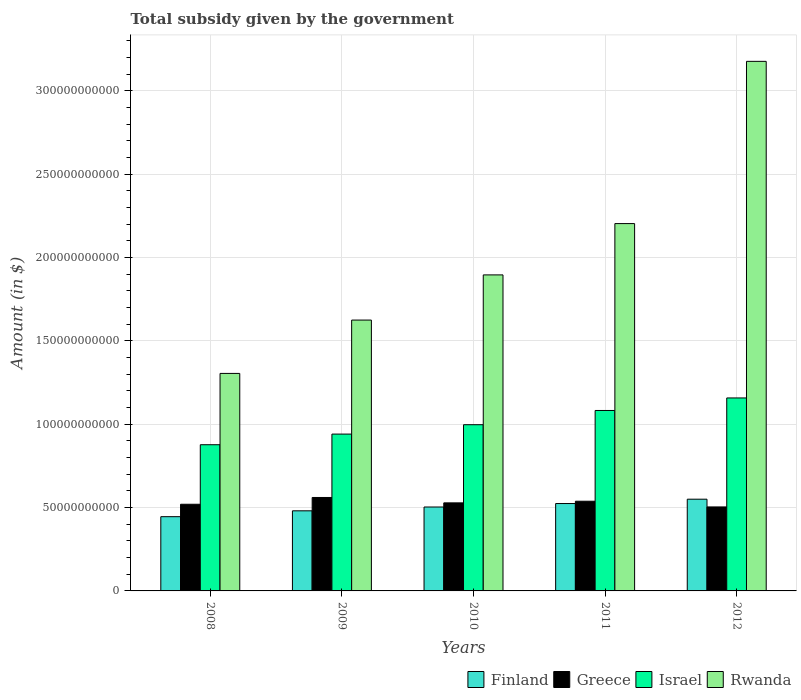Are the number of bars per tick equal to the number of legend labels?
Make the answer very short. Yes. What is the label of the 2nd group of bars from the left?
Give a very brief answer. 2009. In how many cases, is the number of bars for a given year not equal to the number of legend labels?
Keep it short and to the point. 0. What is the total revenue collected by the government in Finland in 2010?
Your answer should be very brief. 5.03e+1. Across all years, what is the maximum total revenue collected by the government in Rwanda?
Offer a very short reply. 3.18e+11. Across all years, what is the minimum total revenue collected by the government in Greece?
Give a very brief answer. 5.04e+1. In which year was the total revenue collected by the government in Israel minimum?
Offer a terse response. 2008. What is the total total revenue collected by the government in Greece in the graph?
Provide a succinct answer. 2.65e+11. What is the difference between the total revenue collected by the government in Rwanda in 2008 and that in 2010?
Offer a terse response. -5.91e+1. What is the difference between the total revenue collected by the government in Israel in 2011 and the total revenue collected by the government in Rwanda in 2012?
Give a very brief answer. -2.09e+11. What is the average total revenue collected by the government in Rwanda per year?
Your answer should be compact. 2.04e+11. In the year 2010, what is the difference between the total revenue collected by the government in Finland and total revenue collected by the government in Rwanda?
Your answer should be compact. -1.39e+11. In how many years, is the total revenue collected by the government in Greece greater than 50000000000 $?
Offer a very short reply. 5. What is the ratio of the total revenue collected by the government in Israel in 2010 to that in 2012?
Your answer should be compact. 0.86. Is the total revenue collected by the government in Israel in 2010 less than that in 2012?
Offer a terse response. Yes. What is the difference between the highest and the second highest total revenue collected by the government in Greece?
Keep it short and to the point. 2.25e+09. What is the difference between the highest and the lowest total revenue collected by the government in Finland?
Give a very brief answer. 1.05e+1. Is the sum of the total revenue collected by the government in Finland in 2010 and 2011 greater than the maximum total revenue collected by the government in Israel across all years?
Provide a short and direct response. No. What does the 1st bar from the left in 2011 represents?
Keep it short and to the point. Finland. What does the 1st bar from the right in 2012 represents?
Your answer should be very brief. Rwanda. How many bars are there?
Offer a terse response. 20. Are all the bars in the graph horizontal?
Your answer should be compact. No. How many years are there in the graph?
Keep it short and to the point. 5. What is the difference between two consecutive major ticks on the Y-axis?
Ensure brevity in your answer.  5.00e+1. Does the graph contain any zero values?
Provide a short and direct response. No. Where does the legend appear in the graph?
Your answer should be compact. Bottom right. How many legend labels are there?
Ensure brevity in your answer.  4. What is the title of the graph?
Give a very brief answer. Total subsidy given by the government. What is the label or title of the X-axis?
Keep it short and to the point. Years. What is the label or title of the Y-axis?
Give a very brief answer. Amount (in $). What is the Amount (in $) in Finland in 2008?
Provide a short and direct response. 4.45e+1. What is the Amount (in $) of Greece in 2008?
Offer a very short reply. 5.20e+1. What is the Amount (in $) of Israel in 2008?
Offer a very short reply. 8.77e+1. What is the Amount (in $) in Rwanda in 2008?
Keep it short and to the point. 1.30e+11. What is the Amount (in $) in Finland in 2009?
Your answer should be compact. 4.80e+1. What is the Amount (in $) of Greece in 2009?
Make the answer very short. 5.60e+1. What is the Amount (in $) in Israel in 2009?
Offer a terse response. 9.41e+1. What is the Amount (in $) in Rwanda in 2009?
Provide a succinct answer. 1.62e+11. What is the Amount (in $) in Finland in 2010?
Make the answer very short. 5.03e+1. What is the Amount (in $) of Greece in 2010?
Your answer should be very brief. 5.28e+1. What is the Amount (in $) of Israel in 2010?
Keep it short and to the point. 9.97e+1. What is the Amount (in $) of Rwanda in 2010?
Keep it short and to the point. 1.90e+11. What is the Amount (in $) in Finland in 2011?
Your answer should be compact. 5.24e+1. What is the Amount (in $) in Greece in 2011?
Give a very brief answer. 5.38e+1. What is the Amount (in $) in Israel in 2011?
Offer a very short reply. 1.08e+11. What is the Amount (in $) of Rwanda in 2011?
Offer a very short reply. 2.20e+11. What is the Amount (in $) of Finland in 2012?
Keep it short and to the point. 5.50e+1. What is the Amount (in $) of Greece in 2012?
Make the answer very short. 5.04e+1. What is the Amount (in $) in Israel in 2012?
Your response must be concise. 1.16e+11. What is the Amount (in $) of Rwanda in 2012?
Provide a succinct answer. 3.18e+11. Across all years, what is the maximum Amount (in $) in Finland?
Your answer should be very brief. 5.50e+1. Across all years, what is the maximum Amount (in $) of Greece?
Give a very brief answer. 5.60e+1. Across all years, what is the maximum Amount (in $) of Israel?
Provide a succinct answer. 1.16e+11. Across all years, what is the maximum Amount (in $) of Rwanda?
Your response must be concise. 3.18e+11. Across all years, what is the minimum Amount (in $) of Finland?
Your answer should be compact. 4.45e+1. Across all years, what is the minimum Amount (in $) in Greece?
Offer a very short reply. 5.04e+1. Across all years, what is the minimum Amount (in $) in Israel?
Your answer should be compact. 8.77e+1. Across all years, what is the minimum Amount (in $) of Rwanda?
Provide a short and direct response. 1.30e+11. What is the total Amount (in $) in Finland in the graph?
Provide a succinct answer. 2.50e+11. What is the total Amount (in $) in Greece in the graph?
Make the answer very short. 2.65e+11. What is the total Amount (in $) of Israel in the graph?
Make the answer very short. 5.05e+11. What is the total Amount (in $) of Rwanda in the graph?
Your answer should be very brief. 1.02e+12. What is the difference between the Amount (in $) in Finland in 2008 and that in 2009?
Provide a succinct answer. -3.52e+09. What is the difference between the Amount (in $) in Greece in 2008 and that in 2009?
Make the answer very short. -4.07e+09. What is the difference between the Amount (in $) of Israel in 2008 and that in 2009?
Make the answer very short. -6.38e+09. What is the difference between the Amount (in $) in Rwanda in 2008 and that in 2009?
Ensure brevity in your answer.  -3.20e+1. What is the difference between the Amount (in $) in Finland in 2008 and that in 2010?
Ensure brevity in your answer.  -5.80e+09. What is the difference between the Amount (in $) in Greece in 2008 and that in 2010?
Ensure brevity in your answer.  -8.33e+08. What is the difference between the Amount (in $) of Israel in 2008 and that in 2010?
Keep it short and to the point. -1.20e+1. What is the difference between the Amount (in $) in Rwanda in 2008 and that in 2010?
Give a very brief answer. -5.91e+1. What is the difference between the Amount (in $) in Finland in 2008 and that in 2011?
Make the answer very short. -7.89e+09. What is the difference between the Amount (in $) of Greece in 2008 and that in 2011?
Give a very brief answer. -1.82e+09. What is the difference between the Amount (in $) in Israel in 2008 and that in 2011?
Your answer should be compact. -2.05e+1. What is the difference between the Amount (in $) in Rwanda in 2008 and that in 2011?
Your response must be concise. -8.99e+1. What is the difference between the Amount (in $) in Finland in 2008 and that in 2012?
Your answer should be very brief. -1.05e+1. What is the difference between the Amount (in $) of Greece in 2008 and that in 2012?
Your answer should be compact. 1.60e+09. What is the difference between the Amount (in $) of Israel in 2008 and that in 2012?
Offer a terse response. -2.81e+1. What is the difference between the Amount (in $) in Rwanda in 2008 and that in 2012?
Provide a short and direct response. -1.87e+11. What is the difference between the Amount (in $) of Finland in 2009 and that in 2010?
Make the answer very short. -2.28e+09. What is the difference between the Amount (in $) of Greece in 2009 and that in 2010?
Ensure brevity in your answer.  3.24e+09. What is the difference between the Amount (in $) of Israel in 2009 and that in 2010?
Your answer should be very brief. -5.62e+09. What is the difference between the Amount (in $) of Rwanda in 2009 and that in 2010?
Your response must be concise. -2.71e+1. What is the difference between the Amount (in $) of Finland in 2009 and that in 2011?
Keep it short and to the point. -4.37e+09. What is the difference between the Amount (in $) of Greece in 2009 and that in 2011?
Provide a short and direct response. 2.25e+09. What is the difference between the Amount (in $) in Israel in 2009 and that in 2011?
Give a very brief answer. -1.42e+1. What is the difference between the Amount (in $) in Rwanda in 2009 and that in 2011?
Provide a succinct answer. -5.79e+1. What is the difference between the Amount (in $) of Finland in 2009 and that in 2012?
Provide a short and direct response. -6.97e+09. What is the difference between the Amount (in $) of Greece in 2009 and that in 2012?
Keep it short and to the point. 5.67e+09. What is the difference between the Amount (in $) in Israel in 2009 and that in 2012?
Your response must be concise. -2.17e+1. What is the difference between the Amount (in $) of Rwanda in 2009 and that in 2012?
Provide a succinct answer. -1.55e+11. What is the difference between the Amount (in $) in Finland in 2010 and that in 2011?
Your answer should be very brief. -2.09e+09. What is the difference between the Amount (in $) in Greece in 2010 and that in 2011?
Keep it short and to the point. -9.91e+08. What is the difference between the Amount (in $) of Israel in 2010 and that in 2011?
Your answer should be compact. -8.54e+09. What is the difference between the Amount (in $) in Rwanda in 2010 and that in 2011?
Your response must be concise. -3.08e+1. What is the difference between the Amount (in $) of Finland in 2010 and that in 2012?
Ensure brevity in your answer.  -4.69e+09. What is the difference between the Amount (in $) in Greece in 2010 and that in 2012?
Your answer should be very brief. 2.43e+09. What is the difference between the Amount (in $) of Israel in 2010 and that in 2012?
Provide a short and direct response. -1.61e+1. What is the difference between the Amount (in $) of Rwanda in 2010 and that in 2012?
Offer a terse response. -1.28e+11. What is the difference between the Amount (in $) in Finland in 2011 and that in 2012?
Keep it short and to the point. -2.60e+09. What is the difference between the Amount (in $) in Greece in 2011 and that in 2012?
Give a very brief answer. 3.42e+09. What is the difference between the Amount (in $) in Israel in 2011 and that in 2012?
Provide a succinct answer. -7.51e+09. What is the difference between the Amount (in $) of Rwanda in 2011 and that in 2012?
Offer a very short reply. -9.73e+1. What is the difference between the Amount (in $) of Finland in 2008 and the Amount (in $) of Greece in 2009?
Give a very brief answer. -1.15e+1. What is the difference between the Amount (in $) of Finland in 2008 and the Amount (in $) of Israel in 2009?
Offer a very short reply. -4.95e+1. What is the difference between the Amount (in $) of Finland in 2008 and the Amount (in $) of Rwanda in 2009?
Provide a short and direct response. -1.18e+11. What is the difference between the Amount (in $) of Greece in 2008 and the Amount (in $) of Israel in 2009?
Give a very brief answer. -4.21e+1. What is the difference between the Amount (in $) of Greece in 2008 and the Amount (in $) of Rwanda in 2009?
Make the answer very short. -1.10e+11. What is the difference between the Amount (in $) of Israel in 2008 and the Amount (in $) of Rwanda in 2009?
Provide a succinct answer. -7.48e+1. What is the difference between the Amount (in $) of Finland in 2008 and the Amount (in $) of Greece in 2010?
Your answer should be very brief. -8.28e+09. What is the difference between the Amount (in $) of Finland in 2008 and the Amount (in $) of Israel in 2010?
Provide a short and direct response. -5.52e+1. What is the difference between the Amount (in $) of Finland in 2008 and the Amount (in $) of Rwanda in 2010?
Provide a succinct answer. -1.45e+11. What is the difference between the Amount (in $) in Greece in 2008 and the Amount (in $) in Israel in 2010?
Make the answer very short. -4.77e+1. What is the difference between the Amount (in $) in Greece in 2008 and the Amount (in $) in Rwanda in 2010?
Your answer should be very brief. -1.38e+11. What is the difference between the Amount (in $) in Israel in 2008 and the Amount (in $) in Rwanda in 2010?
Keep it short and to the point. -1.02e+11. What is the difference between the Amount (in $) of Finland in 2008 and the Amount (in $) of Greece in 2011?
Your answer should be compact. -9.28e+09. What is the difference between the Amount (in $) of Finland in 2008 and the Amount (in $) of Israel in 2011?
Ensure brevity in your answer.  -6.37e+1. What is the difference between the Amount (in $) in Finland in 2008 and the Amount (in $) in Rwanda in 2011?
Provide a short and direct response. -1.76e+11. What is the difference between the Amount (in $) in Greece in 2008 and the Amount (in $) in Israel in 2011?
Your answer should be very brief. -5.62e+1. What is the difference between the Amount (in $) in Greece in 2008 and the Amount (in $) in Rwanda in 2011?
Give a very brief answer. -1.68e+11. What is the difference between the Amount (in $) of Israel in 2008 and the Amount (in $) of Rwanda in 2011?
Keep it short and to the point. -1.33e+11. What is the difference between the Amount (in $) in Finland in 2008 and the Amount (in $) in Greece in 2012?
Ensure brevity in your answer.  -5.85e+09. What is the difference between the Amount (in $) of Finland in 2008 and the Amount (in $) of Israel in 2012?
Give a very brief answer. -7.12e+1. What is the difference between the Amount (in $) of Finland in 2008 and the Amount (in $) of Rwanda in 2012?
Provide a succinct answer. -2.73e+11. What is the difference between the Amount (in $) of Greece in 2008 and the Amount (in $) of Israel in 2012?
Provide a short and direct response. -6.38e+1. What is the difference between the Amount (in $) of Greece in 2008 and the Amount (in $) of Rwanda in 2012?
Make the answer very short. -2.66e+11. What is the difference between the Amount (in $) of Israel in 2008 and the Amount (in $) of Rwanda in 2012?
Provide a short and direct response. -2.30e+11. What is the difference between the Amount (in $) of Finland in 2009 and the Amount (in $) of Greece in 2010?
Ensure brevity in your answer.  -4.76e+09. What is the difference between the Amount (in $) of Finland in 2009 and the Amount (in $) of Israel in 2010?
Give a very brief answer. -5.16e+1. What is the difference between the Amount (in $) in Finland in 2009 and the Amount (in $) in Rwanda in 2010?
Ensure brevity in your answer.  -1.41e+11. What is the difference between the Amount (in $) of Greece in 2009 and the Amount (in $) of Israel in 2010?
Provide a succinct answer. -4.36e+1. What is the difference between the Amount (in $) of Greece in 2009 and the Amount (in $) of Rwanda in 2010?
Give a very brief answer. -1.33e+11. What is the difference between the Amount (in $) in Israel in 2009 and the Amount (in $) in Rwanda in 2010?
Your answer should be compact. -9.55e+1. What is the difference between the Amount (in $) of Finland in 2009 and the Amount (in $) of Greece in 2011?
Give a very brief answer. -5.75e+09. What is the difference between the Amount (in $) of Finland in 2009 and the Amount (in $) of Israel in 2011?
Give a very brief answer. -6.02e+1. What is the difference between the Amount (in $) in Finland in 2009 and the Amount (in $) in Rwanda in 2011?
Keep it short and to the point. -1.72e+11. What is the difference between the Amount (in $) in Greece in 2009 and the Amount (in $) in Israel in 2011?
Your response must be concise. -5.22e+1. What is the difference between the Amount (in $) of Greece in 2009 and the Amount (in $) of Rwanda in 2011?
Give a very brief answer. -1.64e+11. What is the difference between the Amount (in $) of Israel in 2009 and the Amount (in $) of Rwanda in 2011?
Ensure brevity in your answer.  -1.26e+11. What is the difference between the Amount (in $) of Finland in 2009 and the Amount (in $) of Greece in 2012?
Make the answer very short. -2.33e+09. What is the difference between the Amount (in $) in Finland in 2009 and the Amount (in $) in Israel in 2012?
Keep it short and to the point. -6.77e+1. What is the difference between the Amount (in $) of Finland in 2009 and the Amount (in $) of Rwanda in 2012?
Offer a terse response. -2.70e+11. What is the difference between the Amount (in $) of Greece in 2009 and the Amount (in $) of Israel in 2012?
Make the answer very short. -5.97e+1. What is the difference between the Amount (in $) in Greece in 2009 and the Amount (in $) in Rwanda in 2012?
Keep it short and to the point. -2.62e+11. What is the difference between the Amount (in $) in Israel in 2009 and the Amount (in $) in Rwanda in 2012?
Your response must be concise. -2.24e+11. What is the difference between the Amount (in $) in Finland in 2010 and the Amount (in $) in Greece in 2011?
Your answer should be compact. -3.47e+09. What is the difference between the Amount (in $) in Finland in 2010 and the Amount (in $) in Israel in 2011?
Keep it short and to the point. -5.79e+1. What is the difference between the Amount (in $) of Finland in 2010 and the Amount (in $) of Rwanda in 2011?
Make the answer very short. -1.70e+11. What is the difference between the Amount (in $) of Greece in 2010 and the Amount (in $) of Israel in 2011?
Provide a short and direct response. -5.54e+1. What is the difference between the Amount (in $) of Greece in 2010 and the Amount (in $) of Rwanda in 2011?
Provide a succinct answer. -1.67e+11. What is the difference between the Amount (in $) in Israel in 2010 and the Amount (in $) in Rwanda in 2011?
Your answer should be very brief. -1.21e+11. What is the difference between the Amount (in $) in Finland in 2010 and the Amount (in $) in Greece in 2012?
Your answer should be compact. -5.30e+07. What is the difference between the Amount (in $) of Finland in 2010 and the Amount (in $) of Israel in 2012?
Offer a very short reply. -6.54e+1. What is the difference between the Amount (in $) of Finland in 2010 and the Amount (in $) of Rwanda in 2012?
Your response must be concise. -2.67e+11. What is the difference between the Amount (in $) of Greece in 2010 and the Amount (in $) of Israel in 2012?
Offer a terse response. -6.29e+1. What is the difference between the Amount (in $) in Greece in 2010 and the Amount (in $) in Rwanda in 2012?
Ensure brevity in your answer.  -2.65e+11. What is the difference between the Amount (in $) in Israel in 2010 and the Amount (in $) in Rwanda in 2012?
Ensure brevity in your answer.  -2.18e+11. What is the difference between the Amount (in $) in Finland in 2011 and the Amount (in $) in Greece in 2012?
Give a very brief answer. 2.03e+09. What is the difference between the Amount (in $) of Finland in 2011 and the Amount (in $) of Israel in 2012?
Your answer should be very brief. -6.33e+1. What is the difference between the Amount (in $) in Finland in 2011 and the Amount (in $) in Rwanda in 2012?
Offer a very short reply. -2.65e+11. What is the difference between the Amount (in $) of Greece in 2011 and the Amount (in $) of Israel in 2012?
Offer a very short reply. -6.19e+1. What is the difference between the Amount (in $) in Greece in 2011 and the Amount (in $) in Rwanda in 2012?
Offer a terse response. -2.64e+11. What is the difference between the Amount (in $) of Israel in 2011 and the Amount (in $) of Rwanda in 2012?
Offer a terse response. -2.09e+11. What is the average Amount (in $) of Finland per year?
Give a very brief answer. 5.01e+1. What is the average Amount (in $) of Greece per year?
Give a very brief answer. 5.30e+1. What is the average Amount (in $) in Israel per year?
Offer a very short reply. 1.01e+11. What is the average Amount (in $) in Rwanda per year?
Provide a short and direct response. 2.04e+11. In the year 2008, what is the difference between the Amount (in $) in Finland and Amount (in $) in Greece?
Make the answer very short. -7.45e+09. In the year 2008, what is the difference between the Amount (in $) of Finland and Amount (in $) of Israel?
Give a very brief answer. -4.32e+1. In the year 2008, what is the difference between the Amount (in $) in Finland and Amount (in $) in Rwanda?
Provide a short and direct response. -8.59e+1. In the year 2008, what is the difference between the Amount (in $) in Greece and Amount (in $) in Israel?
Offer a very short reply. -3.57e+1. In the year 2008, what is the difference between the Amount (in $) of Greece and Amount (in $) of Rwanda?
Provide a succinct answer. -7.85e+1. In the year 2008, what is the difference between the Amount (in $) in Israel and Amount (in $) in Rwanda?
Your answer should be compact. -4.28e+1. In the year 2009, what is the difference between the Amount (in $) in Finland and Amount (in $) in Greece?
Your answer should be very brief. -8.00e+09. In the year 2009, what is the difference between the Amount (in $) of Finland and Amount (in $) of Israel?
Offer a terse response. -4.60e+1. In the year 2009, what is the difference between the Amount (in $) of Finland and Amount (in $) of Rwanda?
Provide a short and direct response. -1.14e+11. In the year 2009, what is the difference between the Amount (in $) in Greece and Amount (in $) in Israel?
Make the answer very short. -3.80e+1. In the year 2009, what is the difference between the Amount (in $) of Greece and Amount (in $) of Rwanda?
Your response must be concise. -1.06e+11. In the year 2009, what is the difference between the Amount (in $) in Israel and Amount (in $) in Rwanda?
Give a very brief answer. -6.84e+1. In the year 2010, what is the difference between the Amount (in $) of Finland and Amount (in $) of Greece?
Offer a very short reply. -2.48e+09. In the year 2010, what is the difference between the Amount (in $) of Finland and Amount (in $) of Israel?
Make the answer very short. -4.94e+1. In the year 2010, what is the difference between the Amount (in $) in Finland and Amount (in $) in Rwanda?
Keep it short and to the point. -1.39e+11. In the year 2010, what is the difference between the Amount (in $) in Greece and Amount (in $) in Israel?
Offer a very short reply. -4.69e+1. In the year 2010, what is the difference between the Amount (in $) in Greece and Amount (in $) in Rwanda?
Provide a short and direct response. -1.37e+11. In the year 2010, what is the difference between the Amount (in $) of Israel and Amount (in $) of Rwanda?
Offer a very short reply. -8.98e+1. In the year 2011, what is the difference between the Amount (in $) of Finland and Amount (in $) of Greece?
Your answer should be very brief. -1.39e+09. In the year 2011, what is the difference between the Amount (in $) in Finland and Amount (in $) in Israel?
Keep it short and to the point. -5.58e+1. In the year 2011, what is the difference between the Amount (in $) in Finland and Amount (in $) in Rwanda?
Give a very brief answer. -1.68e+11. In the year 2011, what is the difference between the Amount (in $) in Greece and Amount (in $) in Israel?
Ensure brevity in your answer.  -5.44e+1. In the year 2011, what is the difference between the Amount (in $) of Greece and Amount (in $) of Rwanda?
Your response must be concise. -1.67e+11. In the year 2011, what is the difference between the Amount (in $) of Israel and Amount (in $) of Rwanda?
Your answer should be very brief. -1.12e+11. In the year 2012, what is the difference between the Amount (in $) in Finland and Amount (in $) in Greece?
Your answer should be compact. 4.64e+09. In the year 2012, what is the difference between the Amount (in $) of Finland and Amount (in $) of Israel?
Provide a short and direct response. -6.07e+1. In the year 2012, what is the difference between the Amount (in $) of Finland and Amount (in $) of Rwanda?
Make the answer very short. -2.63e+11. In the year 2012, what is the difference between the Amount (in $) of Greece and Amount (in $) of Israel?
Your answer should be compact. -6.54e+1. In the year 2012, what is the difference between the Amount (in $) in Greece and Amount (in $) in Rwanda?
Your answer should be very brief. -2.67e+11. In the year 2012, what is the difference between the Amount (in $) in Israel and Amount (in $) in Rwanda?
Keep it short and to the point. -2.02e+11. What is the ratio of the Amount (in $) in Finland in 2008 to that in 2009?
Ensure brevity in your answer.  0.93. What is the ratio of the Amount (in $) in Greece in 2008 to that in 2009?
Your answer should be compact. 0.93. What is the ratio of the Amount (in $) of Israel in 2008 to that in 2009?
Keep it short and to the point. 0.93. What is the ratio of the Amount (in $) of Rwanda in 2008 to that in 2009?
Your answer should be very brief. 0.8. What is the ratio of the Amount (in $) of Finland in 2008 to that in 2010?
Keep it short and to the point. 0.88. What is the ratio of the Amount (in $) in Greece in 2008 to that in 2010?
Make the answer very short. 0.98. What is the ratio of the Amount (in $) in Israel in 2008 to that in 2010?
Provide a succinct answer. 0.88. What is the ratio of the Amount (in $) of Rwanda in 2008 to that in 2010?
Make the answer very short. 0.69. What is the ratio of the Amount (in $) in Finland in 2008 to that in 2011?
Your response must be concise. 0.85. What is the ratio of the Amount (in $) of Greece in 2008 to that in 2011?
Ensure brevity in your answer.  0.97. What is the ratio of the Amount (in $) of Israel in 2008 to that in 2011?
Ensure brevity in your answer.  0.81. What is the ratio of the Amount (in $) of Rwanda in 2008 to that in 2011?
Ensure brevity in your answer.  0.59. What is the ratio of the Amount (in $) in Finland in 2008 to that in 2012?
Provide a short and direct response. 0.81. What is the ratio of the Amount (in $) of Greece in 2008 to that in 2012?
Offer a very short reply. 1.03. What is the ratio of the Amount (in $) of Israel in 2008 to that in 2012?
Ensure brevity in your answer.  0.76. What is the ratio of the Amount (in $) of Rwanda in 2008 to that in 2012?
Your answer should be very brief. 0.41. What is the ratio of the Amount (in $) in Finland in 2009 to that in 2010?
Provide a short and direct response. 0.95. What is the ratio of the Amount (in $) of Greece in 2009 to that in 2010?
Your answer should be compact. 1.06. What is the ratio of the Amount (in $) of Israel in 2009 to that in 2010?
Offer a very short reply. 0.94. What is the ratio of the Amount (in $) in Rwanda in 2009 to that in 2010?
Keep it short and to the point. 0.86. What is the ratio of the Amount (in $) of Finland in 2009 to that in 2011?
Provide a succinct answer. 0.92. What is the ratio of the Amount (in $) in Greece in 2009 to that in 2011?
Your response must be concise. 1.04. What is the ratio of the Amount (in $) in Israel in 2009 to that in 2011?
Offer a very short reply. 0.87. What is the ratio of the Amount (in $) in Rwanda in 2009 to that in 2011?
Ensure brevity in your answer.  0.74. What is the ratio of the Amount (in $) of Finland in 2009 to that in 2012?
Provide a succinct answer. 0.87. What is the ratio of the Amount (in $) of Greece in 2009 to that in 2012?
Provide a short and direct response. 1.11. What is the ratio of the Amount (in $) of Israel in 2009 to that in 2012?
Provide a short and direct response. 0.81. What is the ratio of the Amount (in $) of Rwanda in 2009 to that in 2012?
Your answer should be very brief. 0.51. What is the ratio of the Amount (in $) in Finland in 2010 to that in 2011?
Provide a short and direct response. 0.96. What is the ratio of the Amount (in $) in Greece in 2010 to that in 2011?
Give a very brief answer. 0.98. What is the ratio of the Amount (in $) of Israel in 2010 to that in 2011?
Your answer should be very brief. 0.92. What is the ratio of the Amount (in $) in Rwanda in 2010 to that in 2011?
Ensure brevity in your answer.  0.86. What is the ratio of the Amount (in $) in Finland in 2010 to that in 2012?
Your answer should be very brief. 0.91. What is the ratio of the Amount (in $) in Greece in 2010 to that in 2012?
Make the answer very short. 1.05. What is the ratio of the Amount (in $) in Israel in 2010 to that in 2012?
Your response must be concise. 0.86. What is the ratio of the Amount (in $) of Rwanda in 2010 to that in 2012?
Give a very brief answer. 0.6. What is the ratio of the Amount (in $) of Finland in 2011 to that in 2012?
Your response must be concise. 0.95. What is the ratio of the Amount (in $) of Greece in 2011 to that in 2012?
Provide a succinct answer. 1.07. What is the ratio of the Amount (in $) of Israel in 2011 to that in 2012?
Offer a terse response. 0.94. What is the ratio of the Amount (in $) of Rwanda in 2011 to that in 2012?
Your response must be concise. 0.69. What is the difference between the highest and the second highest Amount (in $) of Finland?
Provide a short and direct response. 2.60e+09. What is the difference between the highest and the second highest Amount (in $) of Greece?
Your answer should be very brief. 2.25e+09. What is the difference between the highest and the second highest Amount (in $) in Israel?
Provide a short and direct response. 7.51e+09. What is the difference between the highest and the second highest Amount (in $) of Rwanda?
Your answer should be very brief. 9.73e+1. What is the difference between the highest and the lowest Amount (in $) in Finland?
Offer a terse response. 1.05e+1. What is the difference between the highest and the lowest Amount (in $) in Greece?
Make the answer very short. 5.67e+09. What is the difference between the highest and the lowest Amount (in $) in Israel?
Offer a terse response. 2.81e+1. What is the difference between the highest and the lowest Amount (in $) of Rwanda?
Make the answer very short. 1.87e+11. 